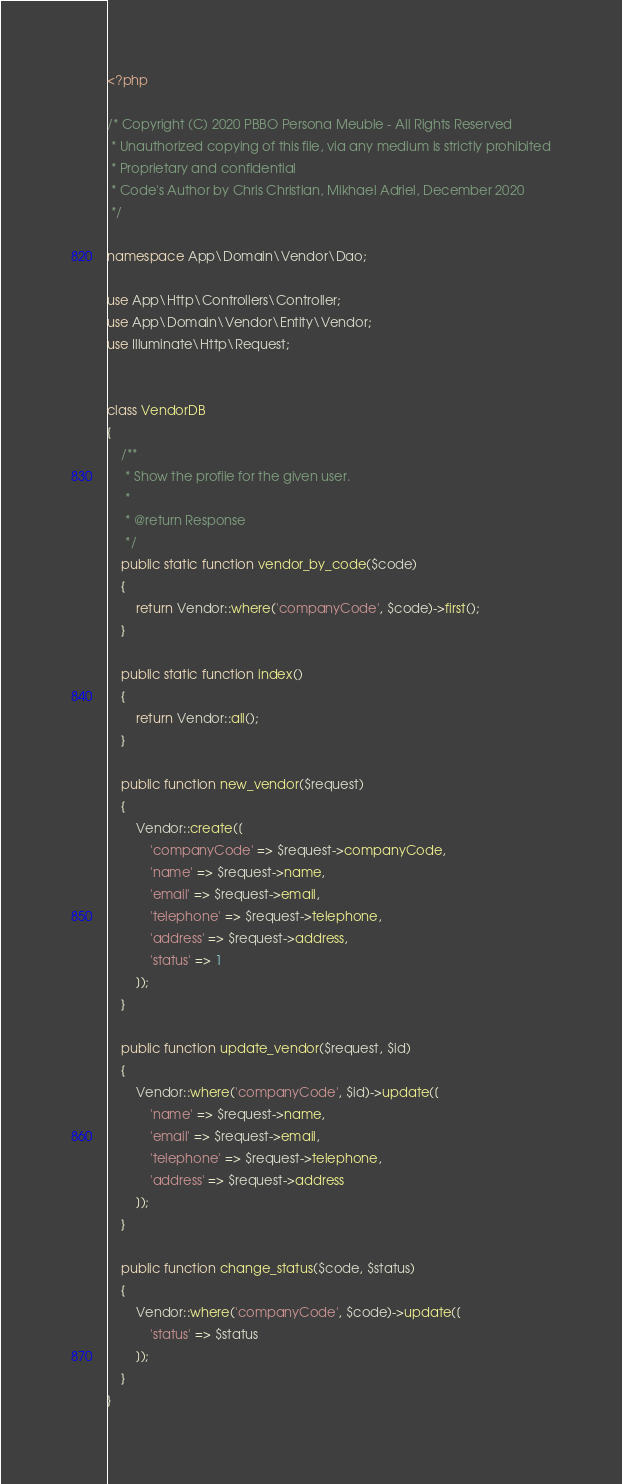Convert code to text. <code><loc_0><loc_0><loc_500><loc_500><_PHP_><?php

/* Copyright (C) 2020 PBBO Persona Meuble - All Rights Reserved
 * Unauthorized copying of this file, via any medium is strictly prohibited
 * Proprietary and confidential
 * Code's Author by Chris Christian, Mikhael Adriel, December 2020
 */

namespace App\Domain\Vendor\Dao;

use App\Http\Controllers\Controller;
use App\Domain\Vendor\Entity\Vendor;
use Illuminate\Http\Request;


class VendorDB
{
    /**
     * Show the profile for the given user.
     *
     * @return Response
     */
    public static function vendor_by_code($code)
    {
        return Vendor::where('companyCode', $code)->first();
    }

    public static function index()
    {
        return Vendor::all();
    }

    public function new_vendor($request)
    {
        Vendor::create([
            'companyCode' => $request->companyCode,
            'name' => $request->name,
            'email' => $request->email,
            'telephone' => $request->telephone,
            'address' => $request->address,
            'status' => 1
        ]);
    }

    public function update_vendor($request, $id)
    {
        Vendor::where('companyCode', $id)->update([
            'name' => $request->name,
            'email' => $request->email,
            'telephone' => $request->telephone,
            'address' => $request->address
        ]);
    }

    public function change_status($code, $status)
    {
        Vendor::where('companyCode', $code)->update([
            'status' => $status
        ]);
    }
}
</code> 